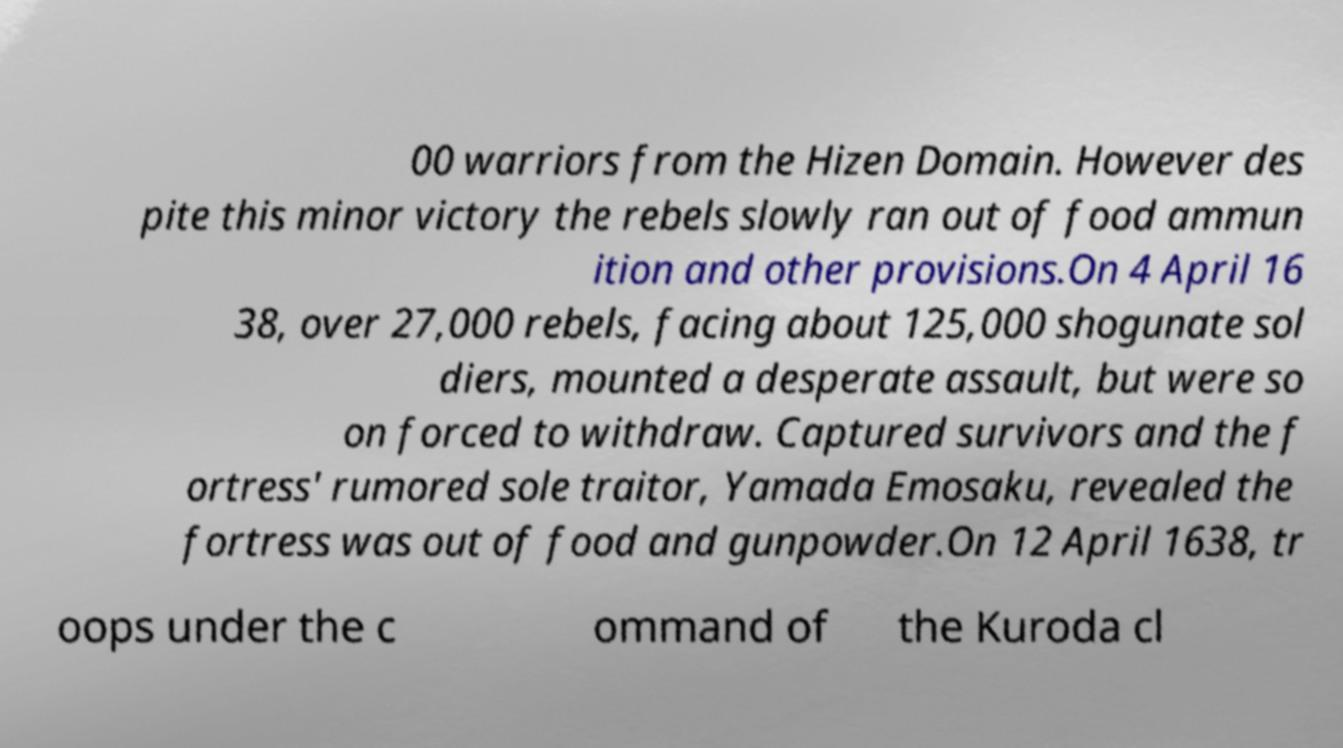Can you read and provide the text displayed in the image?This photo seems to have some interesting text. Can you extract and type it out for me? 00 warriors from the Hizen Domain. However des pite this minor victory the rebels slowly ran out of food ammun ition and other provisions.On 4 April 16 38, over 27,000 rebels, facing about 125,000 shogunate sol diers, mounted a desperate assault, but were so on forced to withdraw. Captured survivors and the f ortress' rumored sole traitor, Yamada Emosaku, revealed the fortress was out of food and gunpowder.On 12 April 1638, tr oops under the c ommand of the Kuroda cl 